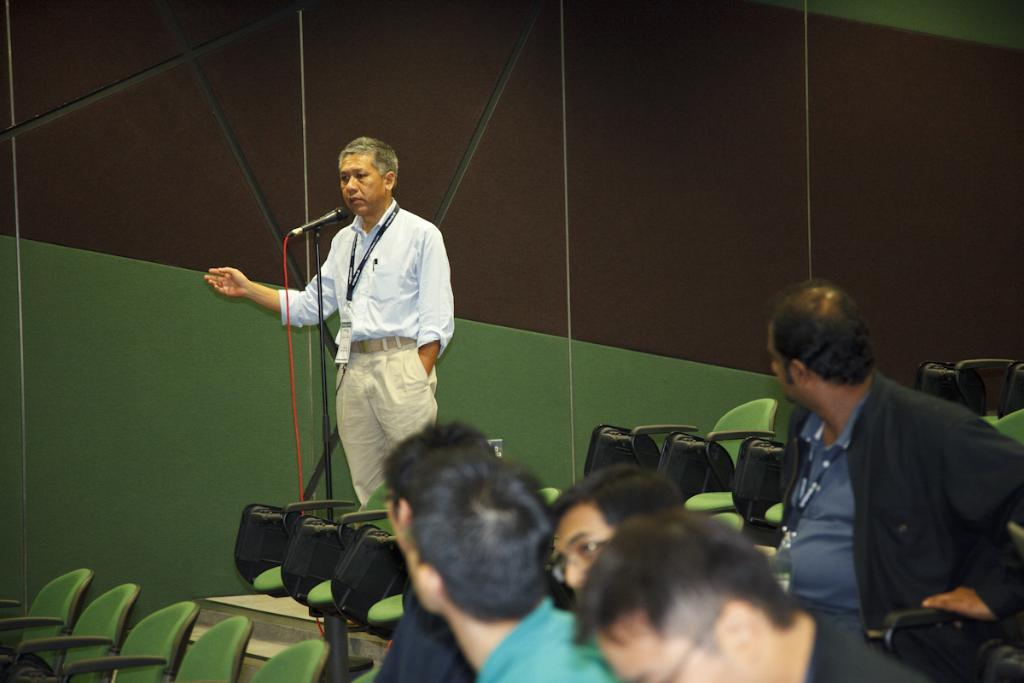What is the person in the image doing? The person is standing and holding a microphone. What else can be seen in the image besides the person with the microphone? There are chairs and people sitting on the chairs in the image. What type of hook is the person using to adjust the texture of the activity in the image? There is no hook or activity involving texture in the image. The person is simply holding a microphone, and there are chairs and people sitting on them. 